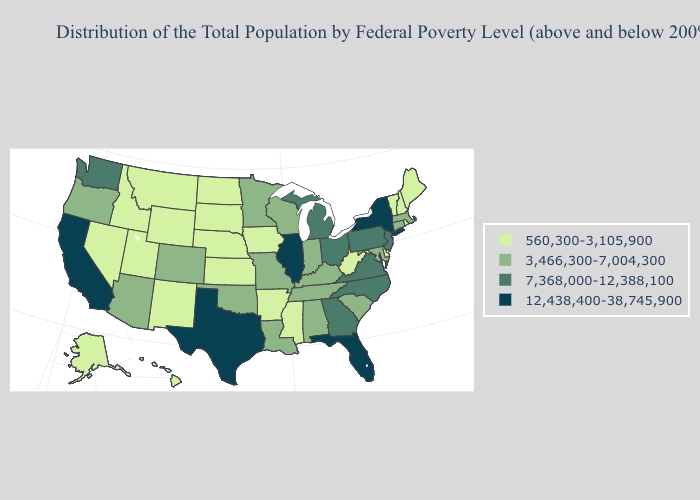Among the states that border Pennsylvania , which have the highest value?
Concise answer only. New York. What is the value of Colorado?
Answer briefly. 3,466,300-7,004,300. Does South Carolina have the lowest value in the USA?
Short answer required. No. Does Wisconsin have the lowest value in the MidWest?
Give a very brief answer. No. Name the states that have a value in the range 3,466,300-7,004,300?
Short answer required. Alabama, Arizona, Colorado, Connecticut, Indiana, Kentucky, Louisiana, Maryland, Massachusetts, Minnesota, Missouri, Oklahoma, Oregon, South Carolina, Tennessee, Wisconsin. Among the states that border Iowa , which have the highest value?
Concise answer only. Illinois. What is the lowest value in states that border California?
Be succinct. 560,300-3,105,900. Does the map have missing data?
Quick response, please. No. Among the states that border West Virginia , does Virginia have the lowest value?
Write a very short answer. No. Among the states that border Vermont , which have the highest value?
Keep it brief. New York. Does Maine have the lowest value in the Northeast?
Answer briefly. Yes. What is the lowest value in the MidWest?
Short answer required. 560,300-3,105,900. What is the value of Ohio?
Write a very short answer. 7,368,000-12,388,100. Name the states that have a value in the range 3,466,300-7,004,300?
Answer briefly. Alabama, Arizona, Colorado, Connecticut, Indiana, Kentucky, Louisiana, Maryland, Massachusetts, Minnesota, Missouri, Oklahoma, Oregon, South Carolina, Tennessee, Wisconsin. What is the value of Minnesota?
Quick response, please. 3,466,300-7,004,300. 